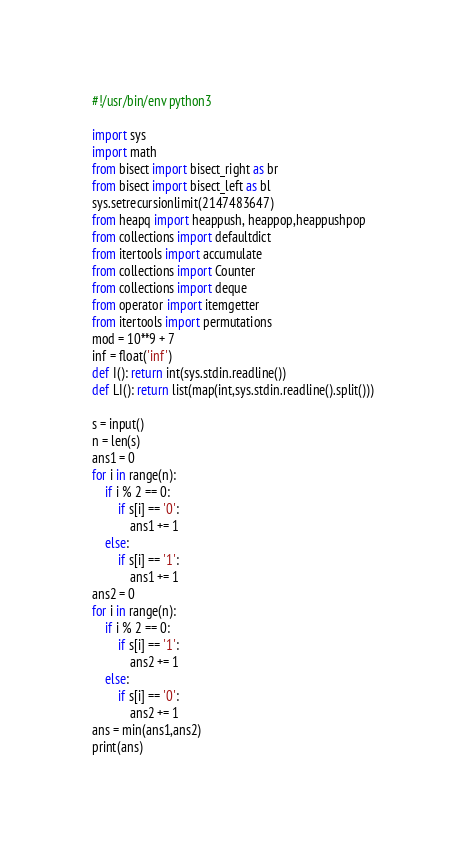Convert code to text. <code><loc_0><loc_0><loc_500><loc_500><_Python_>#!/usr/bin/env python3

import sys
import math
from bisect import bisect_right as br
from bisect import bisect_left as bl
sys.setrecursionlimit(2147483647)
from heapq import heappush, heappop,heappushpop
from collections import defaultdict
from itertools import accumulate
from collections import Counter
from collections import deque
from operator import itemgetter
from itertools import permutations
mod = 10**9 + 7
inf = float('inf')
def I(): return int(sys.stdin.readline())
def LI(): return list(map(int,sys.stdin.readline().split()))

s = input()
n = len(s)
ans1 = 0
for i in range(n):
    if i % 2 == 0:
        if s[i] == '0':
            ans1 += 1
    else:
        if s[i] == '1':
            ans1 += 1
ans2 = 0
for i in range(n):
    if i % 2 == 0:
        if s[i] == '1':
            ans2 += 1
    else:
        if s[i] == '0':
            ans2 += 1
ans = min(ans1,ans2)
print(ans)</code> 